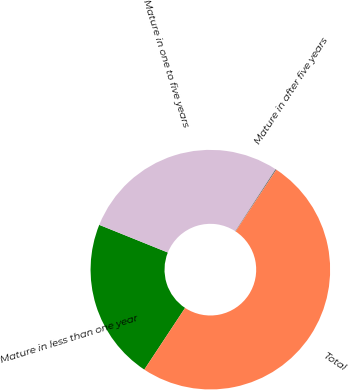Convert chart to OTSL. <chart><loc_0><loc_0><loc_500><loc_500><pie_chart><fcel>Mature in less than one year<fcel>Mature in one to five years<fcel>Mature in after five years<fcel>Total<nl><fcel>21.81%<fcel>28.06%<fcel>0.13%<fcel>50.0%<nl></chart> 